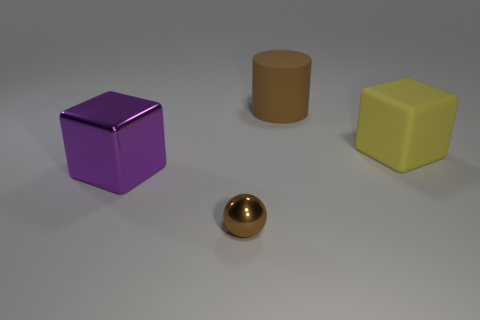Do the purple thing and the big yellow object have the same shape?
Offer a very short reply. Yes. Is the number of metallic objects on the left side of the brown metallic ball the same as the number of large matte cubes?
Your answer should be very brief. Yes. How many big things are in front of the yellow object?
Your response must be concise. 1. What is the size of the shiny ball?
Your answer should be compact. Small. What is the color of the large object that is made of the same material as the sphere?
Offer a terse response. Purple. How many other rubber cubes are the same size as the purple cube?
Your answer should be compact. 1. Do the block on the right side of the brown cylinder and the brown cylinder have the same material?
Keep it short and to the point. Yes. Is the number of brown metal balls behind the large brown thing less than the number of tiny things?
Make the answer very short. Yes. What shape is the object to the right of the large brown object?
Offer a very short reply. Cube. What shape is the purple metal object that is the same size as the yellow rubber thing?
Offer a terse response. Cube. 